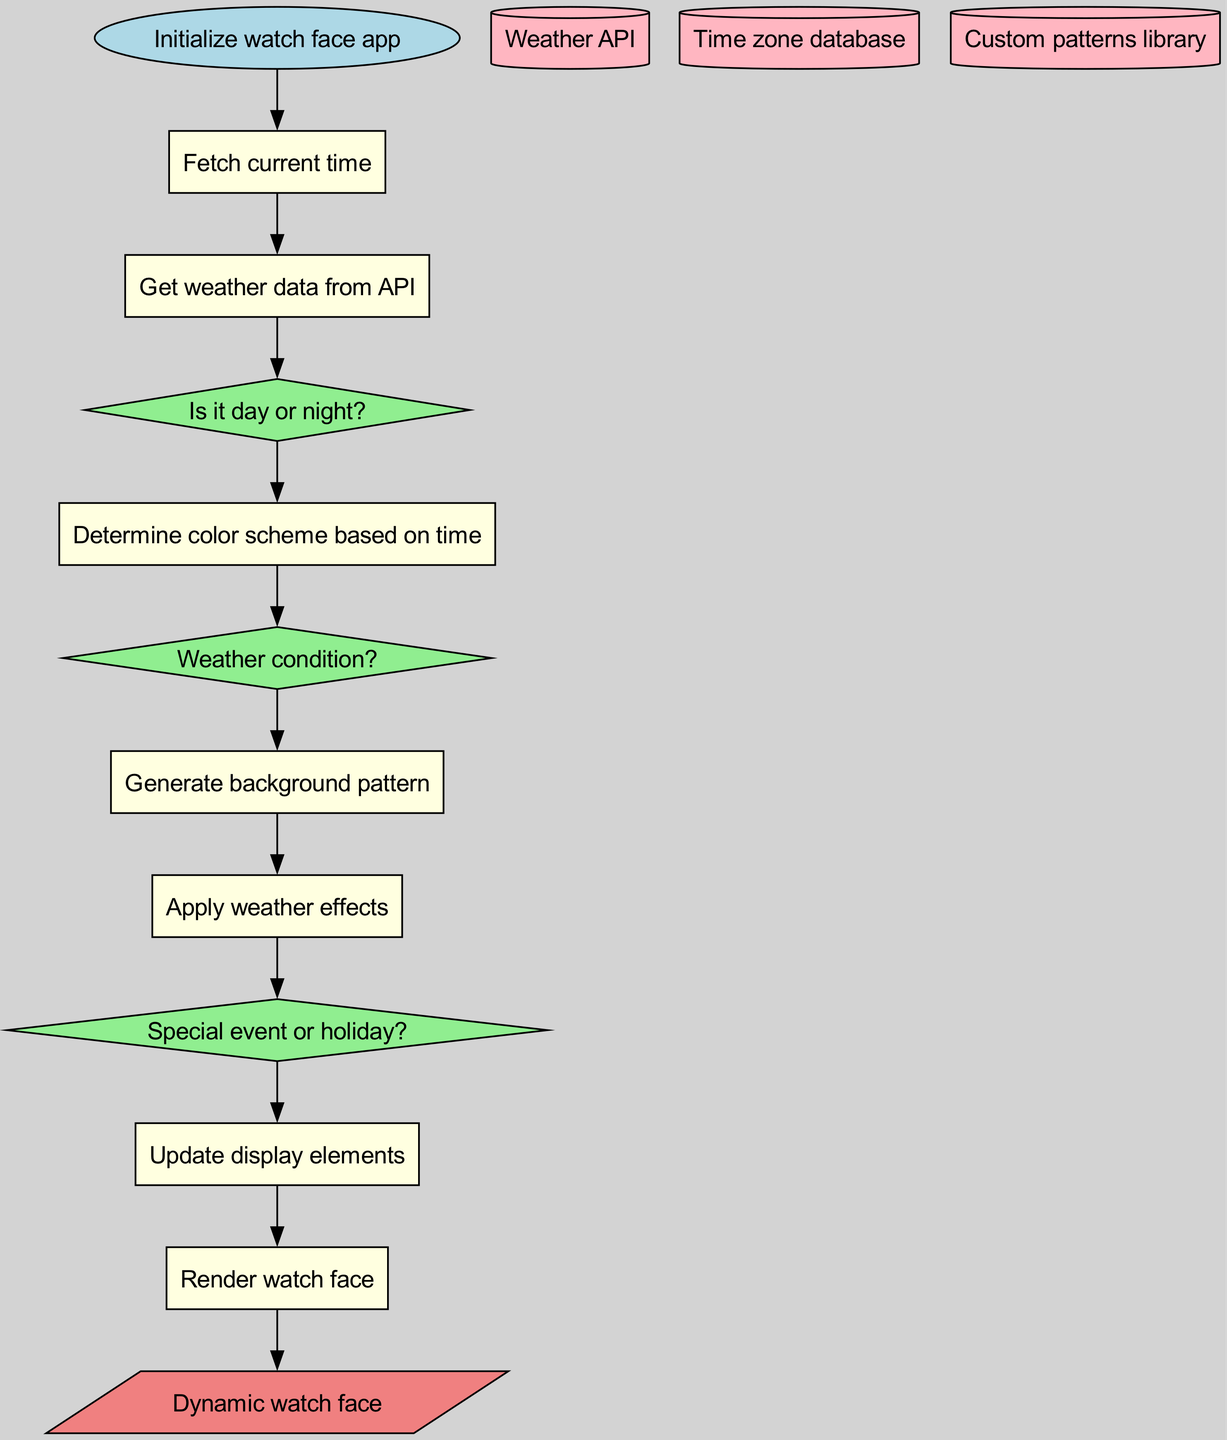What is the first process after initializing the watch face app? The diagram indicates that after the "Initialize watch face app" node, the next step is "Fetch current time." This process is directly linked to the start node.
Answer: Fetch current time How many decision nodes are present in this diagram? There are three decision nodes: "Is it day or night?", "Weather condition?", and "Special event or holiday?". Counting them gives a total of three.
Answer: Three What is the output of the entire process represented in the diagram? The final output is indicated as "Dynamic watch face," which is the end product of all preceding processes and decisions.
Answer: Dynamic watch face Which process directly follows checking the weather condition? After "Weather condition?", the next process in the flow is "Generate background pattern," indicating that the system generates a pattern based on the current weather.
Answer: Generate background pattern What data store is used to fetch weather data? The diagram includes "Weather API" as a data store used for obtaining current weather conditions. This is the specific data resource referenced in the flow.
Answer: Weather API How many nodes are there in total in the diagram? By counting, we have one start node, six process nodes, three decision nodes, three data store nodes, and one output node, totaling 14 nodes.
Answer: Fourteen What is the purpose of the "Update display elements" process? The purpose of this process is to modify the elements on the watch face based on the decisions made earlier, particularly influenced by weather and special events.
Answer: Modify elements Which two processes are connected to the decision about whether it is day or night? The decision "Is it day or night?" is connected to two processes: "Determine color scheme based on time" and "Get weather data from API." This indicates that both processes are influenced by this decision.
Answer: Determine color scheme based on time and Get weather data from API What is the shape of the node representing the decision about special events or holidays? In the flowchart, decision nodes are represented with a diamond shape. Therefore, the "Special event or holiday?" node also adopts this shape for consistency.
Answer: Diamond 